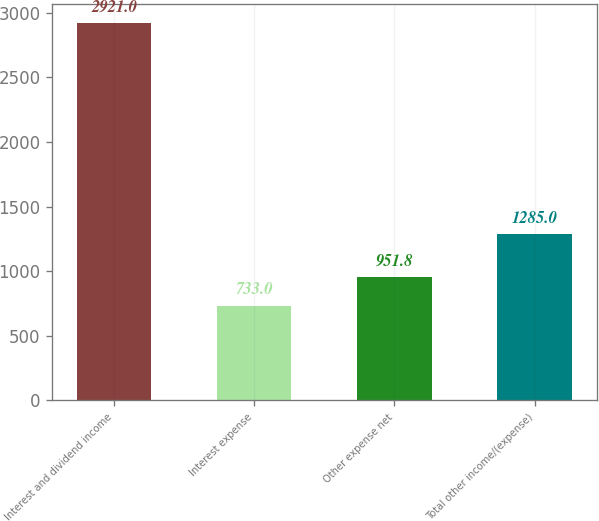Convert chart. <chart><loc_0><loc_0><loc_500><loc_500><bar_chart><fcel>Interest and dividend income<fcel>Interest expense<fcel>Other expense net<fcel>Total other income/(expense)<nl><fcel>2921<fcel>733<fcel>951.8<fcel>1285<nl></chart> 